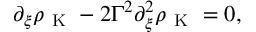Convert formula to latex. <formula><loc_0><loc_0><loc_500><loc_500>\begin{array} { r } { \partial _ { \xi } \rho _ { K } - 2 \Gamma ^ { 2 } \partial _ { \xi } ^ { 2 } \rho _ { K } = 0 , } \end{array}</formula> 